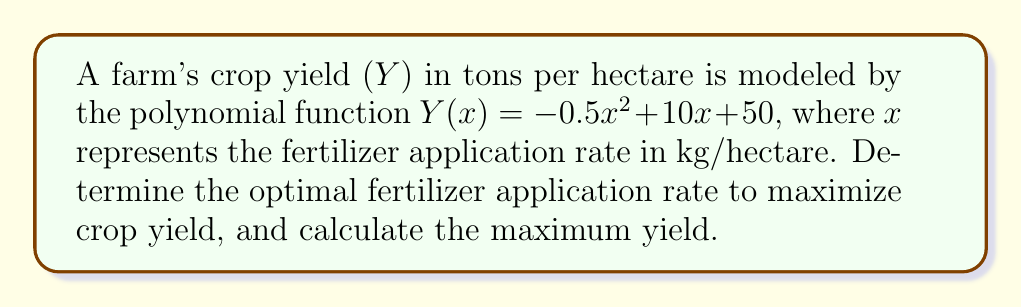Provide a solution to this math problem. To solve this problem, we'll follow these steps:

1) The yield function is a quadratic polynomial: $Y(x) = -0.5x^2 + 10x + 50$

2) To find the maximum yield, we need to find the vertex of this parabola. The x-coordinate of the vertex will give us the optimal fertilizer application rate.

3) For a quadratic function in the form $f(x) = ax^2 + bx + c$, the x-coordinate of the vertex is given by $x = -\frac{b}{2a}$

4) In our case, $a = -0.5$, $b = 10$, and $c = 50$

5) Calculating the optimal fertilizer rate:

   $x = -\frac{b}{2a} = -\frac{10}{2(-0.5)} = -\frac{10}{-1} = 10$

6) The optimal fertilizer application rate is 10 kg/hectare.

7) To find the maximum yield, we substitute x = 10 into the original function:

   $Y(10) = -0.5(10)^2 + 10(10) + 50$
   $= -0.5(100) + 100 + 50$
   $= -50 + 100 + 50$
   $= 100$

8) Therefore, the maximum yield is 100 tons per hectare.
Answer: Optimal rate: 10 kg/ha; Maximum yield: 100 tons/ha 